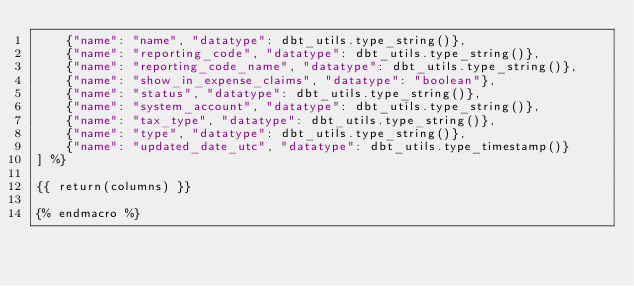Convert code to text. <code><loc_0><loc_0><loc_500><loc_500><_SQL_>    {"name": "name", "datatype": dbt_utils.type_string()},
    {"name": "reporting_code", "datatype": dbt_utils.type_string()},
    {"name": "reporting_code_name", "datatype": dbt_utils.type_string()},
    {"name": "show_in_expense_claims", "datatype": "boolean"},
    {"name": "status", "datatype": dbt_utils.type_string()},
    {"name": "system_account", "datatype": dbt_utils.type_string()},
    {"name": "tax_type", "datatype": dbt_utils.type_string()},
    {"name": "type", "datatype": dbt_utils.type_string()},
    {"name": "updated_date_utc", "datatype": dbt_utils.type_timestamp()}
] %}

{{ return(columns) }}

{% endmacro %}
</code> 